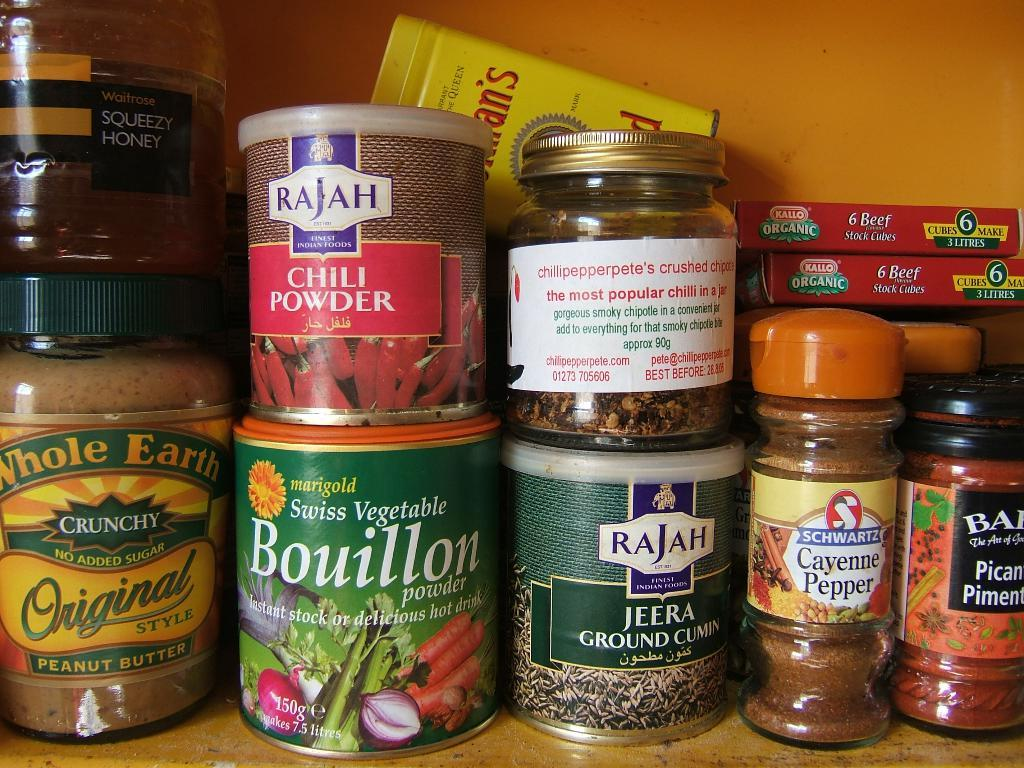What types of containers are visible in the image? There are bottles, jars, and packets in the image. Where are these containers located? These items are on a shelf. What can be seen in the background of the image? There is a wall visible in the background of the image. Can we determine the location of the image based on the available information? The image may have been taken in a room, but we cannot definitively determine the location. How many cakes are being weighed on the scale in the image? There is no scale or cakes present in the image. Can you tell me the color of the donkey in the image? There is no donkey present in the image. 